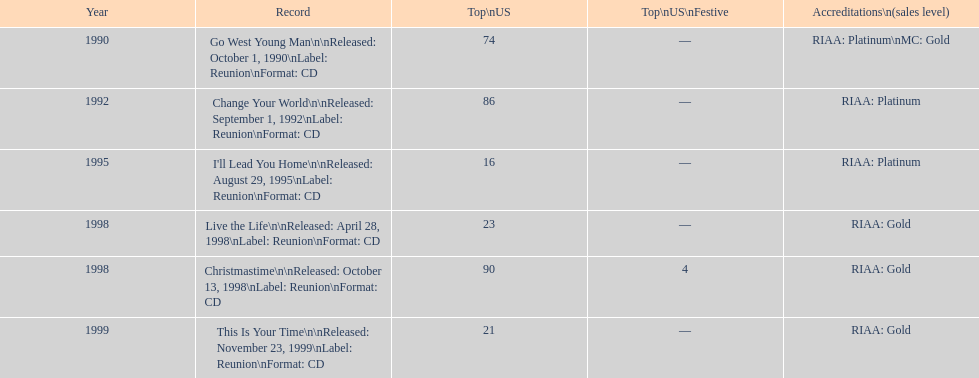Can you give me this table as a dict? {'header': ['Year', 'Record', 'Top\\nUS', 'Top\\nUS\\nFestive', 'Accreditations\\n(sales level)'], 'rows': [['1990', 'Go West Young Man\\n\\nReleased: October 1, 1990\\nLabel: Reunion\\nFormat: CD', '74', '—', 'RIAA: Platinum\\nMC: Gold'], ['1992', 'Change Your World\\n\\nReleased: September 1, 1992\\nLabel: Reunion\\nFormat: CD', '86', '—', 'RIAA: Platinum'], ['1995', "I'll Lead You Home\\n\\nReleased: August 29, 1995\\nLabel: Reunion\\nFormat: CD", '16', '—', 'RIAA: Platinum'], ['1998', 'Live the Life\\n\\nReleased: April 28, 1998\\nLabel: Reunion\\nFormat: CD', '23', '—', 'RIAA: Gold'], ['1998', 'Christmastime\\n\\nReleased: October 13, 1998\\nLabel: Reunion\\nFormat: CD', '90', '4', 'RIAA: Gold'], ['1999', 'This Is Your Time\\n\\nReleased: November 23, 1999\\nLabel: Reunion\\nFormat: CD', '21', '—', 'RIAA: Gold']]} How many tracks are there from 1998 in the list? 2. 